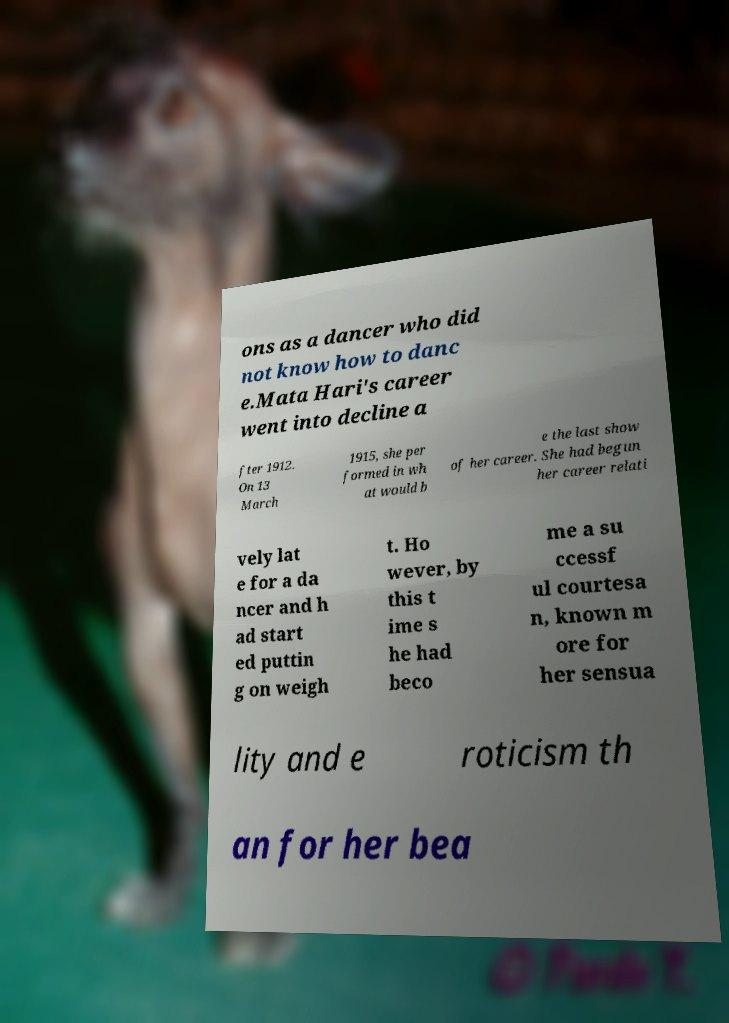For documentation purposes, I need the text within this image transcribed. Could you provide that? ons as a dancer who did not know how to danc e.Mata Hari's career went into decline a fter 1912. On 13 March 1915, she per formed in wh at would b e the last show of her career. She had begun her career relati vely lat e for a da ncer and h ad start ed puttin g on weigh t. Ho wever, by this t ime s he had beco me a su ccessf ul courtesa n, known m ore for her sensua lity and e roticism th an for her bea 